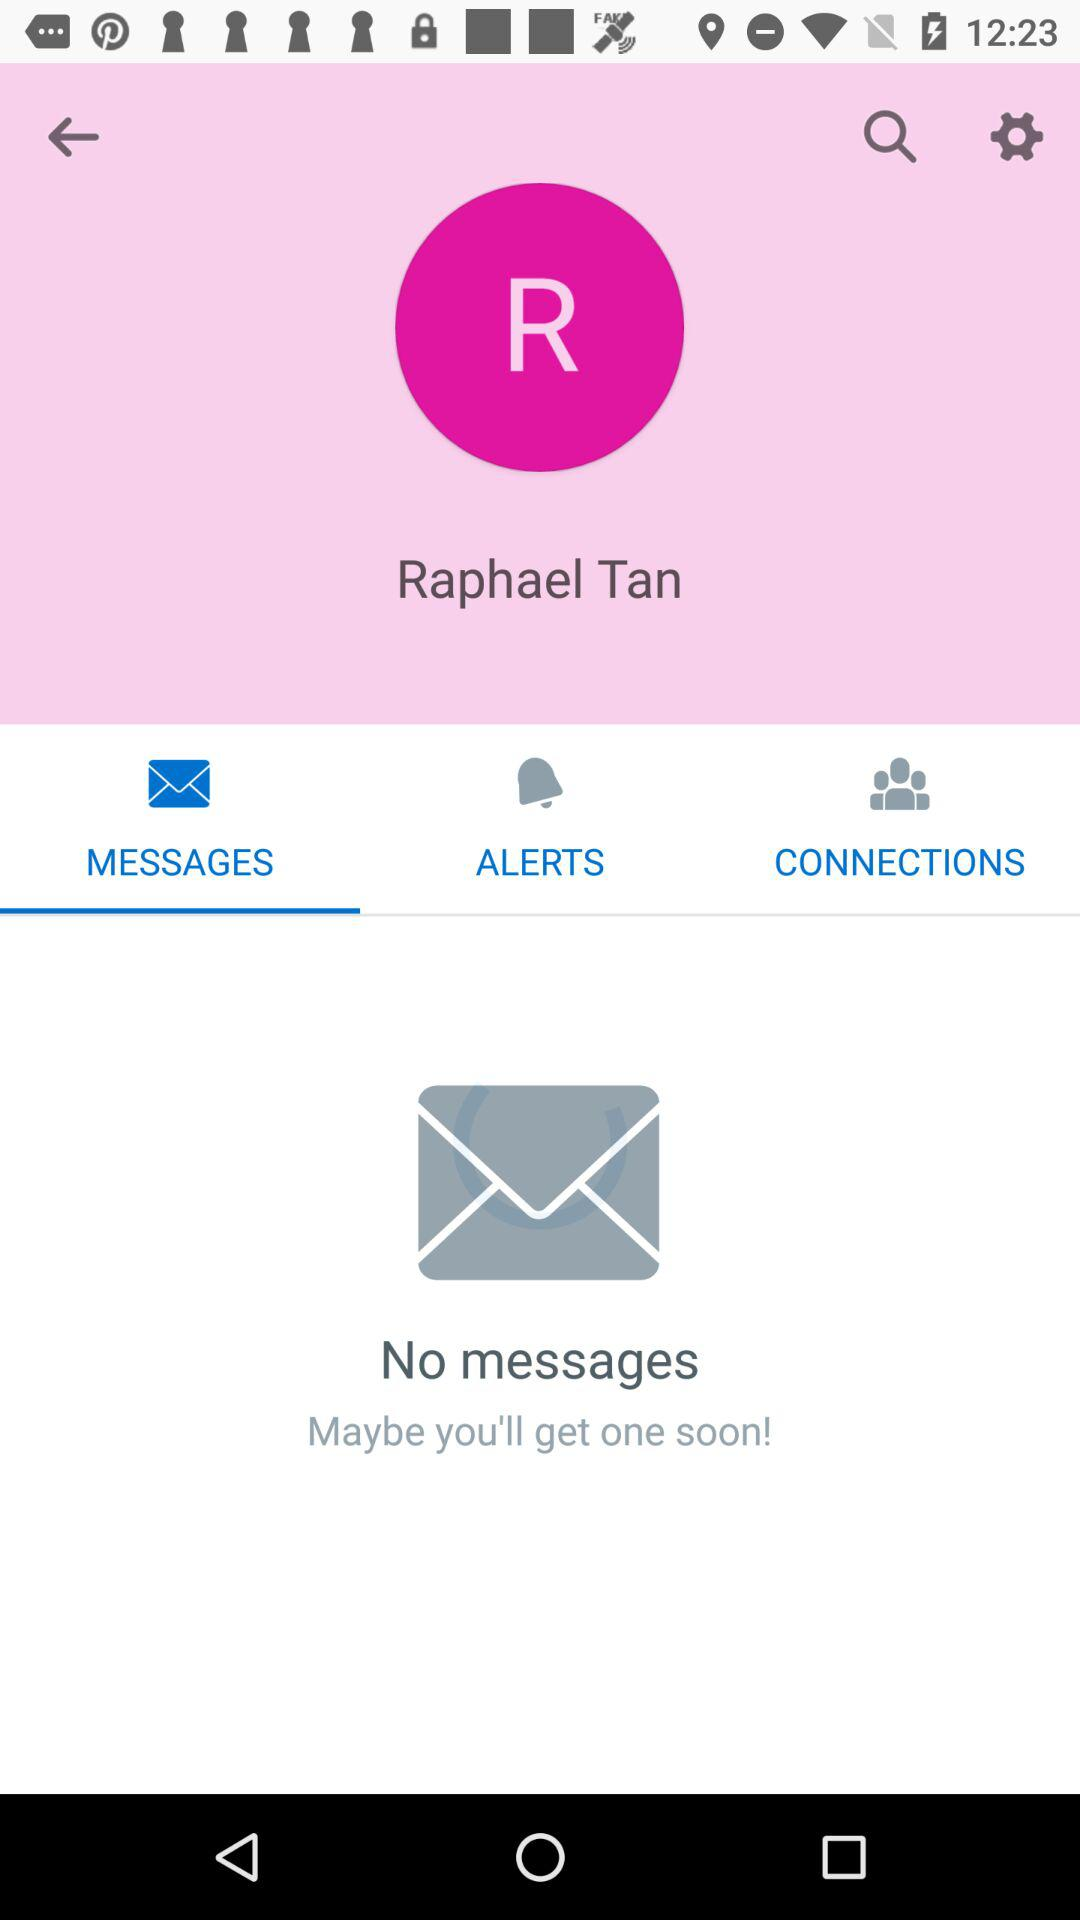Does the user have any messages? The user has no messages. 